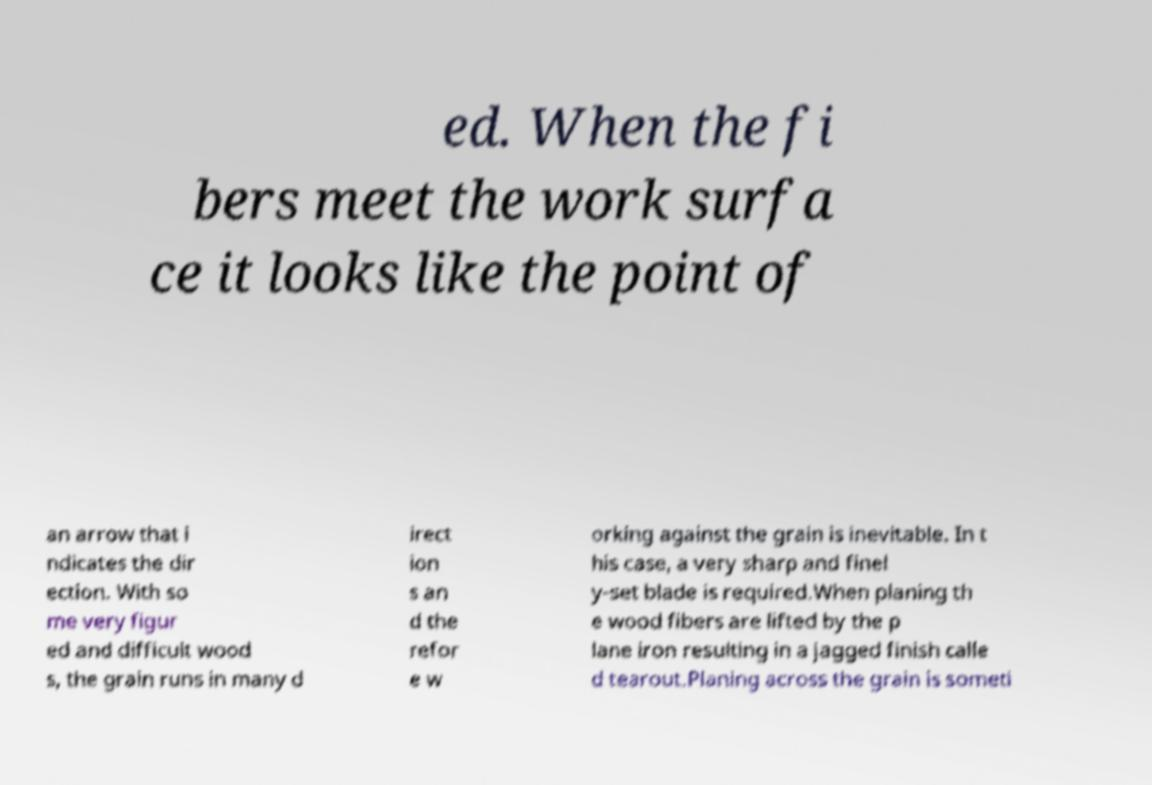Please identify and transcribe the text found in this image. ed. When the fi bers meet the work surfa ce it looks like the point of an arrow that i ndicates the dir ection. With so me very figur ed and difficult wood s, the grain runs in many d irect ion s an d the refor e w orking against the grain is inevitable. In t his case, a very sharp and finel y-set blade is required.When planing th e wood fibers are lifted by the p lane iron resulting in a jagged finish calle d tearout.Planing across the grain is someti 